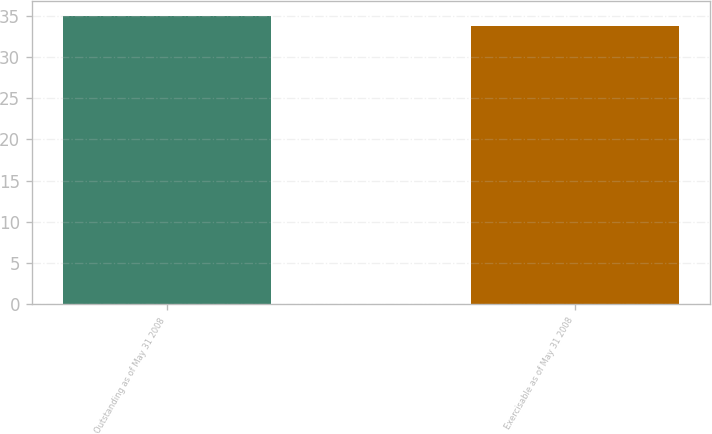Convert chart. <chart><loc_0><loc_0><loc_500><loc_500><bar_chart><fcel>Outstanding as of May 31 2008<fcel>Exercisable as of May 31 2008<nl><fcel>35<fcel>33.77<nl></chart> 